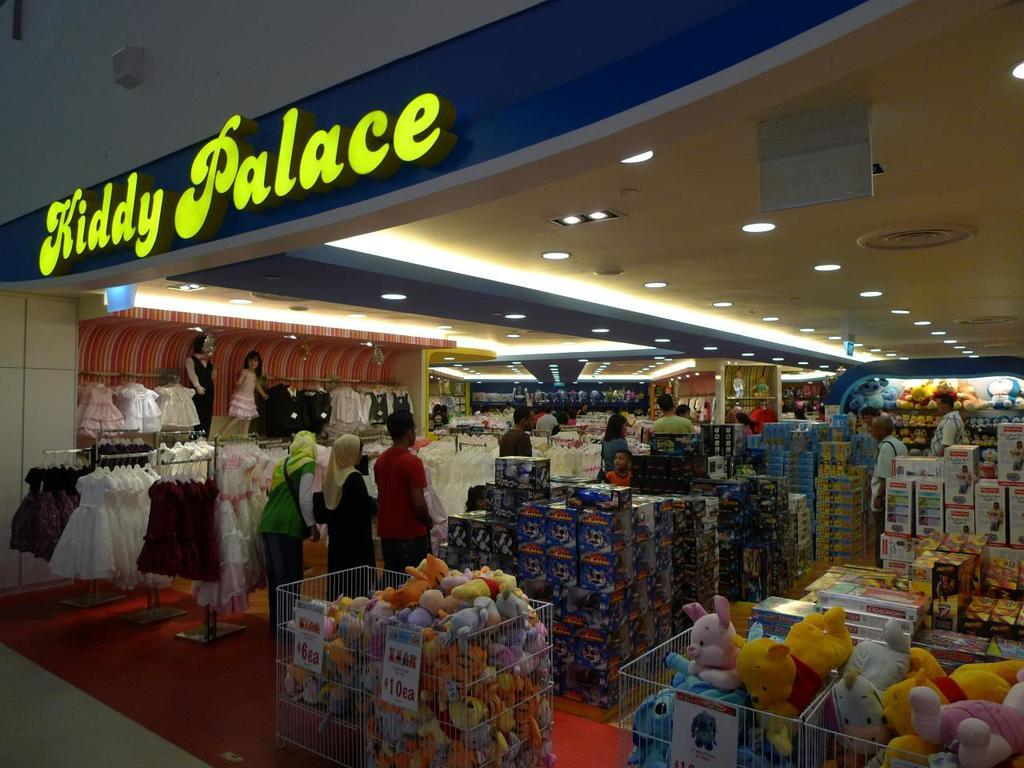<image>
Summarize the visual content of the image. A store called Kiddy Palace that sells kids toys 